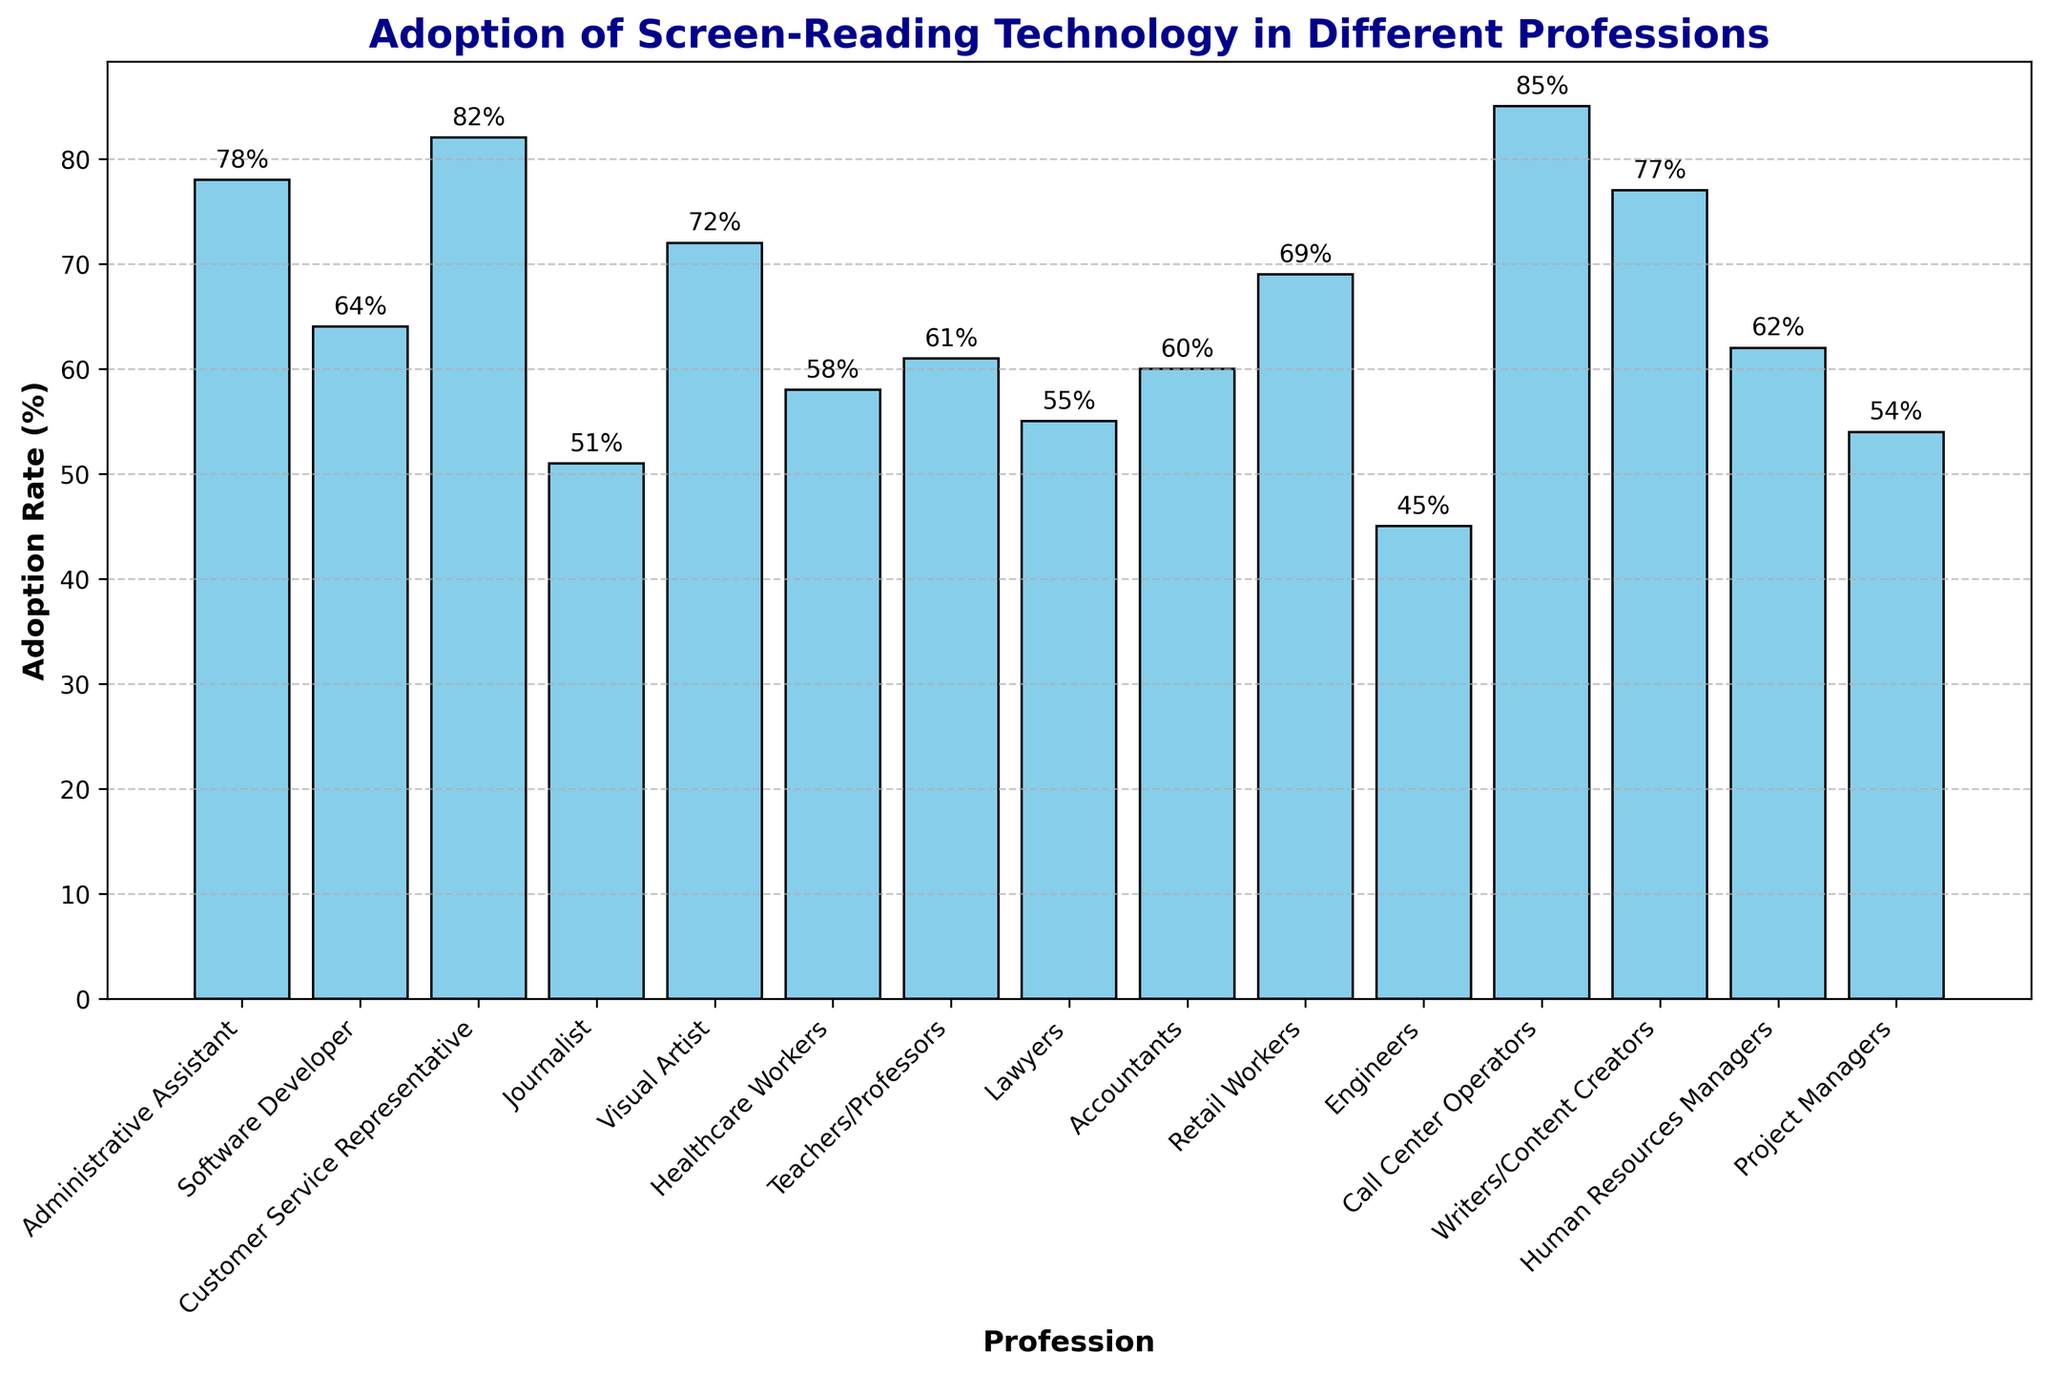What profession has the highest adoption rate of screen-reading technology? First, identify the tallest bar in the bar chart. Then read the corresponding profession label on the x-axis.
Answer: Call Center Operators Which two professions have similar adoption rates around 60%? Find bars with heights close to 60%. Check the exact adoption rates labeled on the bars to confirm similarities, then note the professions on the x-axis.
Answer: Teachers/Professors and Accountants What is the difference in adoption rates between Customer Service Representatives and Engineers? Identify the exact adoption rates for Customer Service Representatives (82%) and Engineers (45%) from the bar labels. Subtract the lower value from the higher one.
Answer: 37% Out of Administrative Assistant, Software Developer, and Journalist, which profession has the lowest adoption rate? Compare the adoption rates of the three specified professions by looking at the heights of their bars. Identify the smallest value.
Answer: Journalist Which profession is close to the average adoption rate of all professions listed in the chart? Calculate the average adoption rate by summing all adoption rates and dividing by the number of professions. Find the bar height closest to this average value.
Answer: Human Resources Managers What is the sum of the adoption rates for Visual Artists, Writers/Content Creators, and Lawyers? Identify the adoption rates for Visual Artists (72%), Writers/Content Creators (77%), and Lawyers (55%) from the bar labels. Add these values together.
Answer: 204% How many professions have an adoption rate higher than 70%? Count the number of bars with heights exceeding 70%.
Answer: 6 Among Healthcare Workers, Teachers/Professors, and Project Managers, who has the highest adoption rate? Compare the adoption rates by inspecting the bar heights for each specified profession and identify the highest value.
Answer: Teachers/Professors Which profession has a moderate adoption rate close to 50%? Find the bar whose height is near 50%. Check the adoption rate labeled on the bar to confirm.
Answer: Journalist 